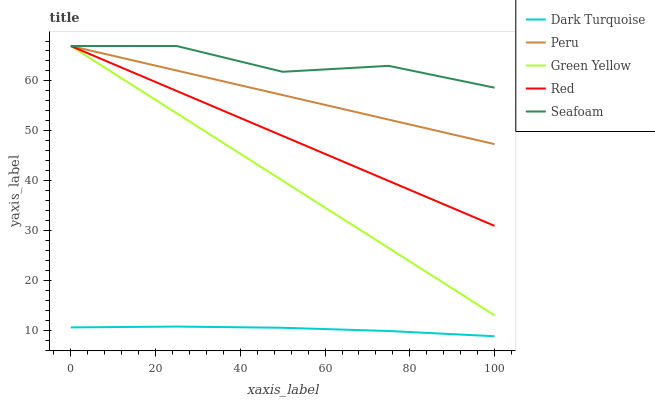Does Dark Turquoise have the minimum area under the curve?
Answer yes or no. Yes. Does Seafoam have the maximum area under the curve?
Answer yes or no. Yes. Does Green Yellow have the minimum area under the curve?
Answer yes or no. No. Does Green Yellow have the maximum area under the curve?
Answer yes or no. No. Is Red the smoothest?
Answer yes or no. Yes. Is Seafoam the roughest?
Answer yes or no. Yes. Is Green Yellow the smoothest?
Answer yes or no. No. Is Green Yellow the roughest?
Answer yes or no. No. Does Green Yellow have the lowest value?
Answer yes or no. No. Does Seafoam have the highest value?
Answer yes or no. Yes. Is Dark Turquoise less than Red?
Answer yes or no. Yes. Is Red greater than Dark Turquoise?
Answer yes or no. Yes. Does Red intersect Green Yellow?
Answer yes or no. Yes. Is Red less than Green Yellow?
Answer yes or no. No. Is Red greater than Green Yellow?
Answer yes or no. No. Does Dark Turquoise intersect Red?
Answer yes or no. No. 